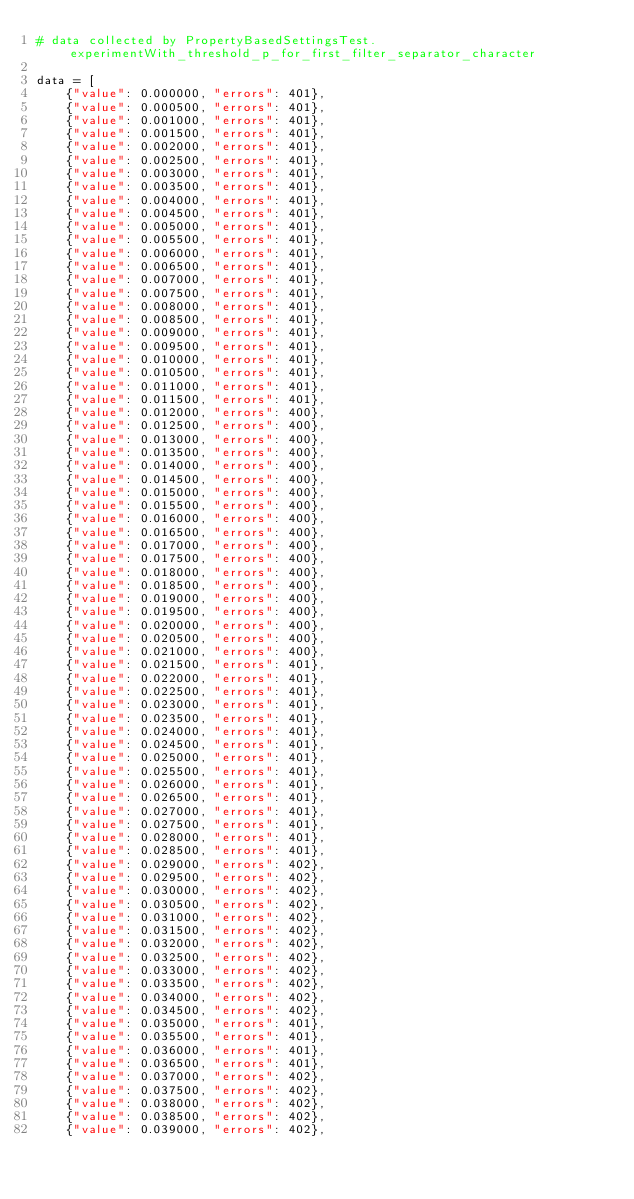Convert code to text. <code><loc_0><loc_0><loc_500><loc_500><_Python_># data collected by PropertyBasedSettingsTest.experimentWith_threshold_p_for_first_filter_separator_character

data = [
    {"value": 0.000000, "errors": 401},
    {"value": 0.000500, "errors": 401},
    {"value": 0.001000, "errors": 401},
    {"value": 0.001500, "errors": 401},
    {"value": 0.002000, "errors": 401},
    {"value": 0.002500, "errors": 401},
    {"value": 0.003000, "errors": 401},
    {"value": 0.003500, "errors": 401},
    {"value": 0.004000, "errors": 401},
    {"value": 0.004500, "errors": 401},
    {"value": 0.005000, "errors": 401},
    {"value": 0.005500, "errors": 401},
    {"value": 0.006000, "errors": 401},
    {"value": 0.006500, "errors": 401},
    {"value": 0.007000, "errors": 401},
    {"value": 0.007500, "errors": 401},
    {"value": 0.008000, "errors": 401},
    {"value": 0.008500, "errors": 401},
    {"value": 0.009000, "errors": 401},
    {"value": 0.009500, "errors": 401},
    {"value": 0.010000, "errors": 401},
    {"value": 0.010500, "errors": 401},
    {"value": 0.011000, "errors": 401},
    {"value": 0.011500, "errors": 401},
    {"value": 0.012000, "errors": 400},
    {"value": 0.012500, "errors": 400},
    {"value": 0.013000, "errors": 400},
    {"value": 0.013500, "errors": 400},
    {"value": 0.014000, "errors": 400},
    {"value": 0.014500, "errors": 400},
    {"value": 0.015000, "errors": 400},
    {"value": 0.015500, "errors": 400},
    {"value": 0.016000, "errors": 400},
    {"value": 0.016500, "errors": 400},
    {"value": 0.017000, "errors": 400},
    {"value": 0.017500, "errors": 400},
    {"value": 0.018000, "errors": 400},
    {"value": 0.018500, "errors": 400},
    {"value": 0.019000, "errors": 400},
    {"value": 0.019500, "errors": 400},
    {"value": 0.020000, "errors": 400},
    {"value": 0.020500, "errors": 400},
    {"value": 0.021000, "errors": 400},
    {"value": 0.021500, "errors": 401},
    {"value": 0.022000, "errors": 401},
    {"value": 0.022500, "errors": 401},
    {"value": 0.023000, "errors": 401},
    {"value": 0.023500, "errors": 401},
    {"value": 0.024000, "errors": 401},
    {"value": 0.024500, "errors": 401},
    {"value": 0.025000, "errors": 401},
    {"value": 0.025500, "errors": 401},
    {"value": 0.026000, "errors": 401},
    {"value": 0.026500, "errors": 401},
    {"value": 0.027000, "errors": 401},
    {"value": 0.027500, "errors": 401},
    {"value": 0.028000, "errors": 401},
    {"value": 0.028500, "errors": 401},
    {"value": 0.029000, "errors": 402},
    {"value": 0.029500, "errors": 402},
    {"value": 0.030000, "errors": 402},
    {"value": 0.030500, "errors": 402},
    {"value": 0.031000, "errors": 402},
    {"value": 0.031500, "errors": 402},
    {"value": 0.032000, "errors": 402},
    {"value": 0.032500, "errors": 402},
    {"value": 0.033000, "errors": 402},
    {"value": 0.033500, "errors": 402},
    {"value": 0.034000, "errors": 402},
    {"value": 0.034500, "errors": 402},
    {"value": 0.035000, "errors": 401},
    {"value": 0.035500, "errors": 401},
    {"value": 0.036000, "errors": 401},
    {"value": 0.036500, "errors": 401},
    {"value": 0.037000, "errors": 402},
    {"value": 0.037500, "errors": 402},
    {"value": 0.038000, "errors": 402},
    {"value": 0.038500, "errors": 402},
    {"value": 0.039000, "errors": 402},</code> 